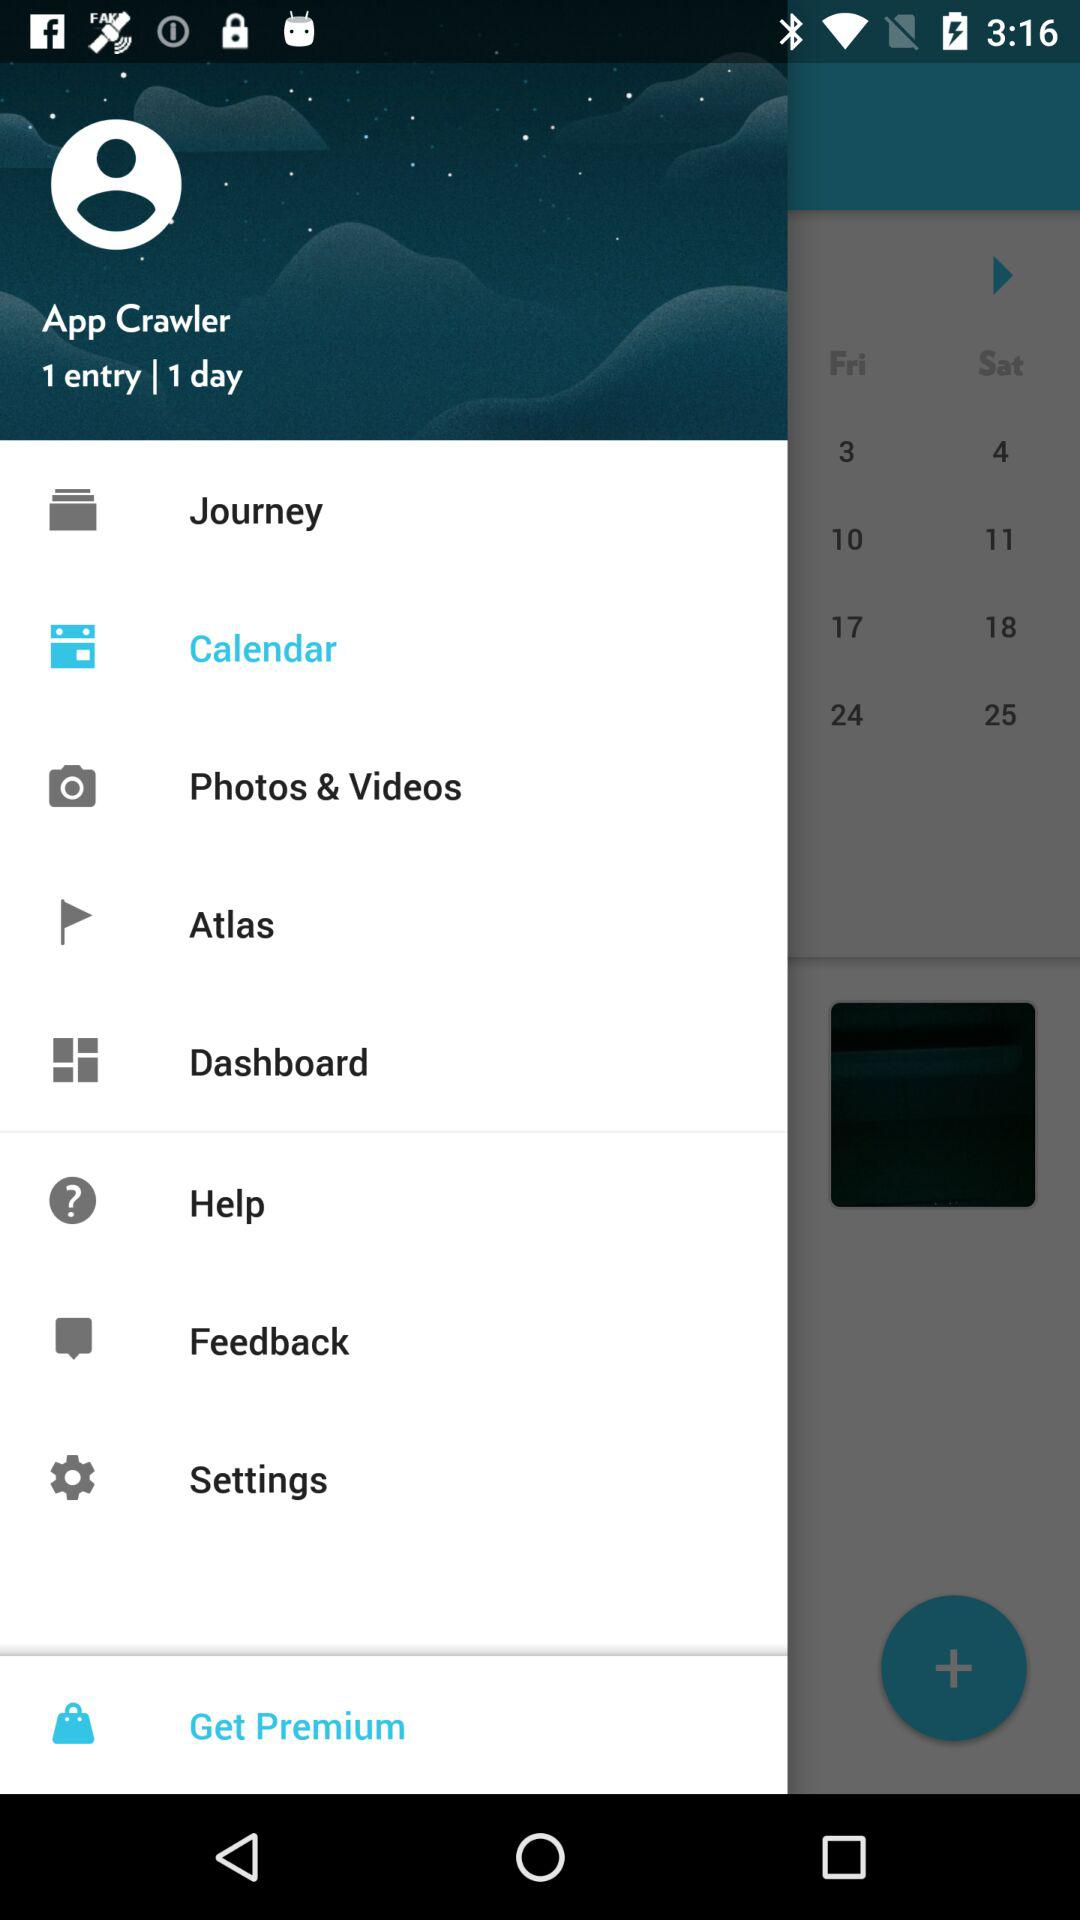Which item is selected in the menu? The selected item in the menu is "Calendar". 